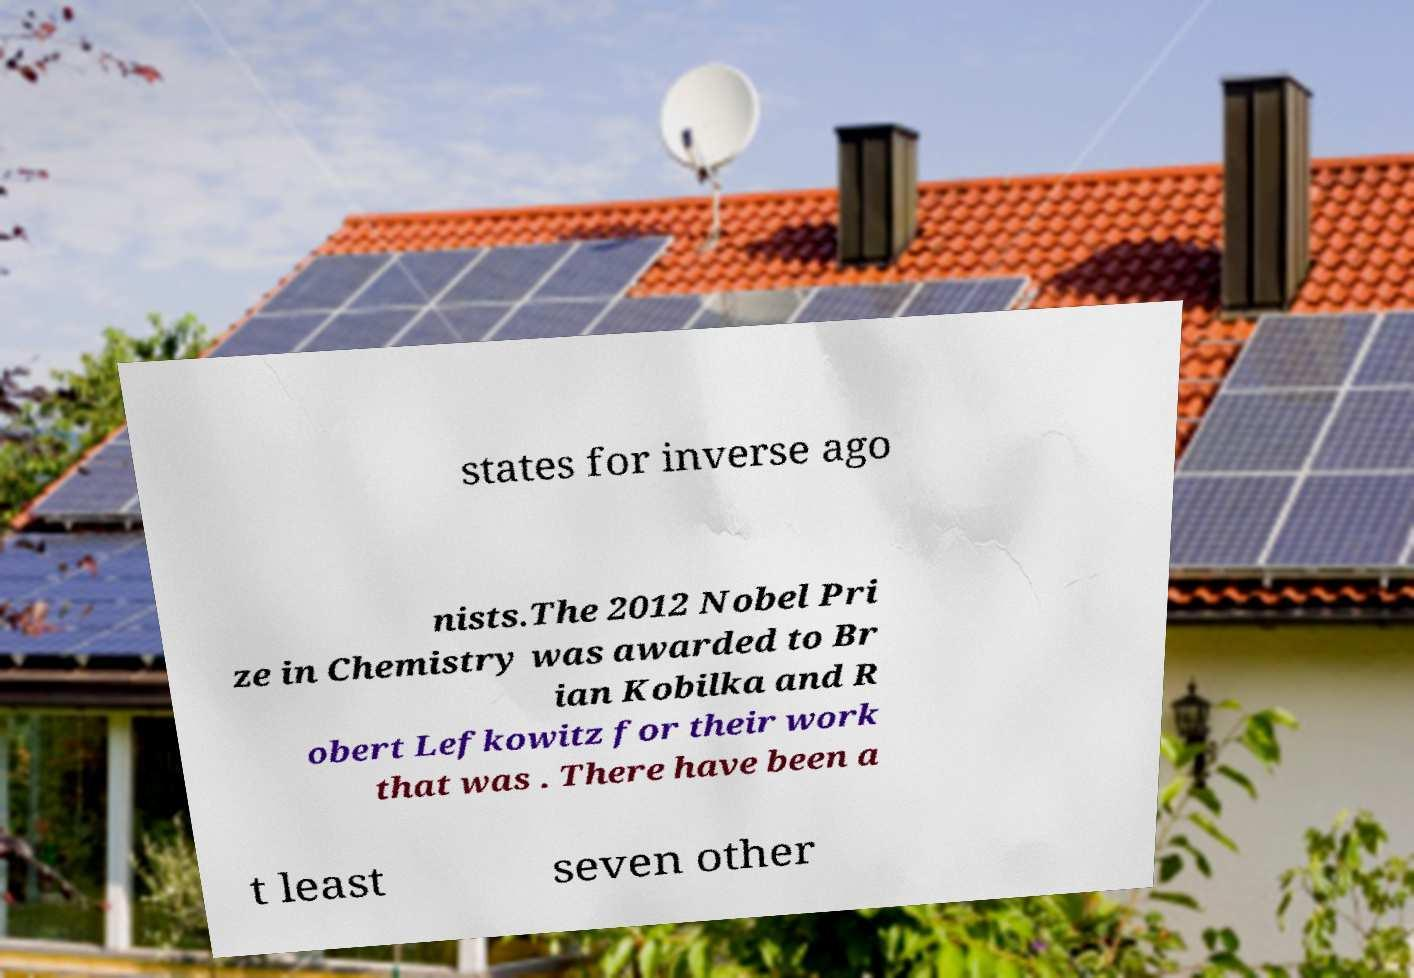Could you extract and type out the text from this image? states for inverse ago nists.The 2012 Nobel Pri ze in Chemistry was awarded to Br ian Kobilka and R obert Lefkowitz for their work that was . There have been a t least seven other 